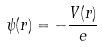Convert formula to latex. <formula><loc_0><loc_0><loc_500><loc_500>\psi ( r ) = - \frac { V ( r ) } { e }</formula> 